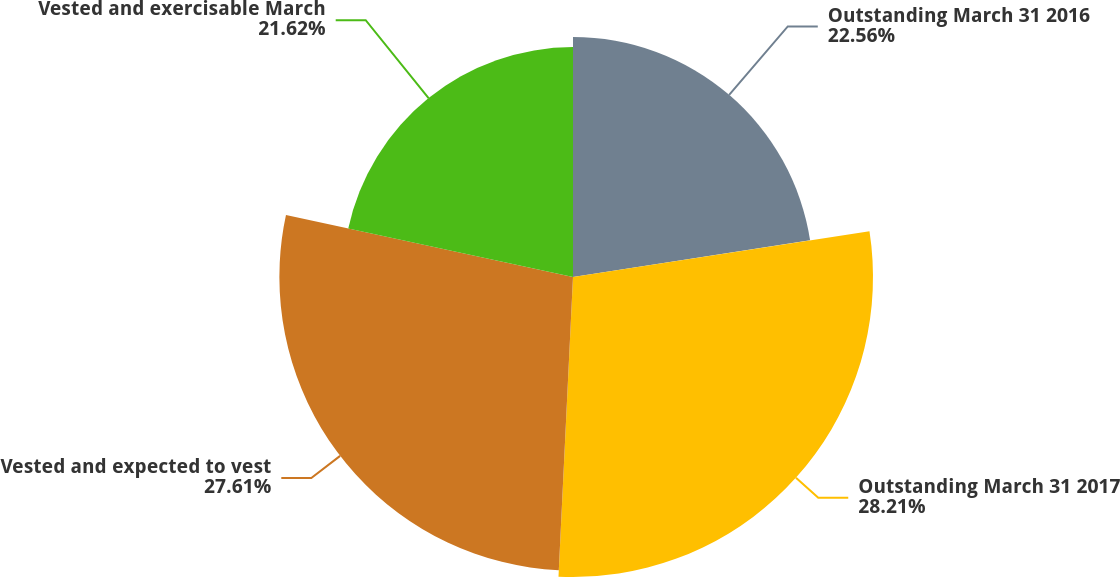<chart> <loc_0><loc_0><loc_500><loc_500><pie_chart><fcel>Outstanding March 31 2016<fcel>Outstanding March 31 2017<fcel>Vested and expected to vest<fcel>Vested and exercisable March<nl><fcel>22.56%<fcel>28.21%<fcel>27.61%<fcel>21.62%<nl></chart> 